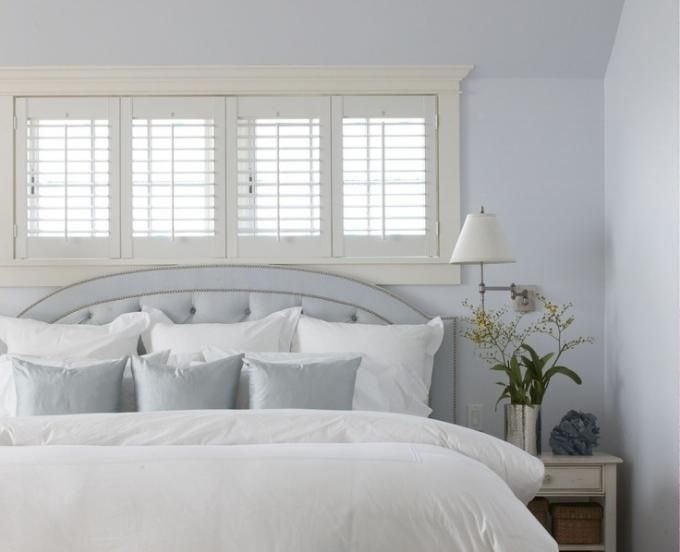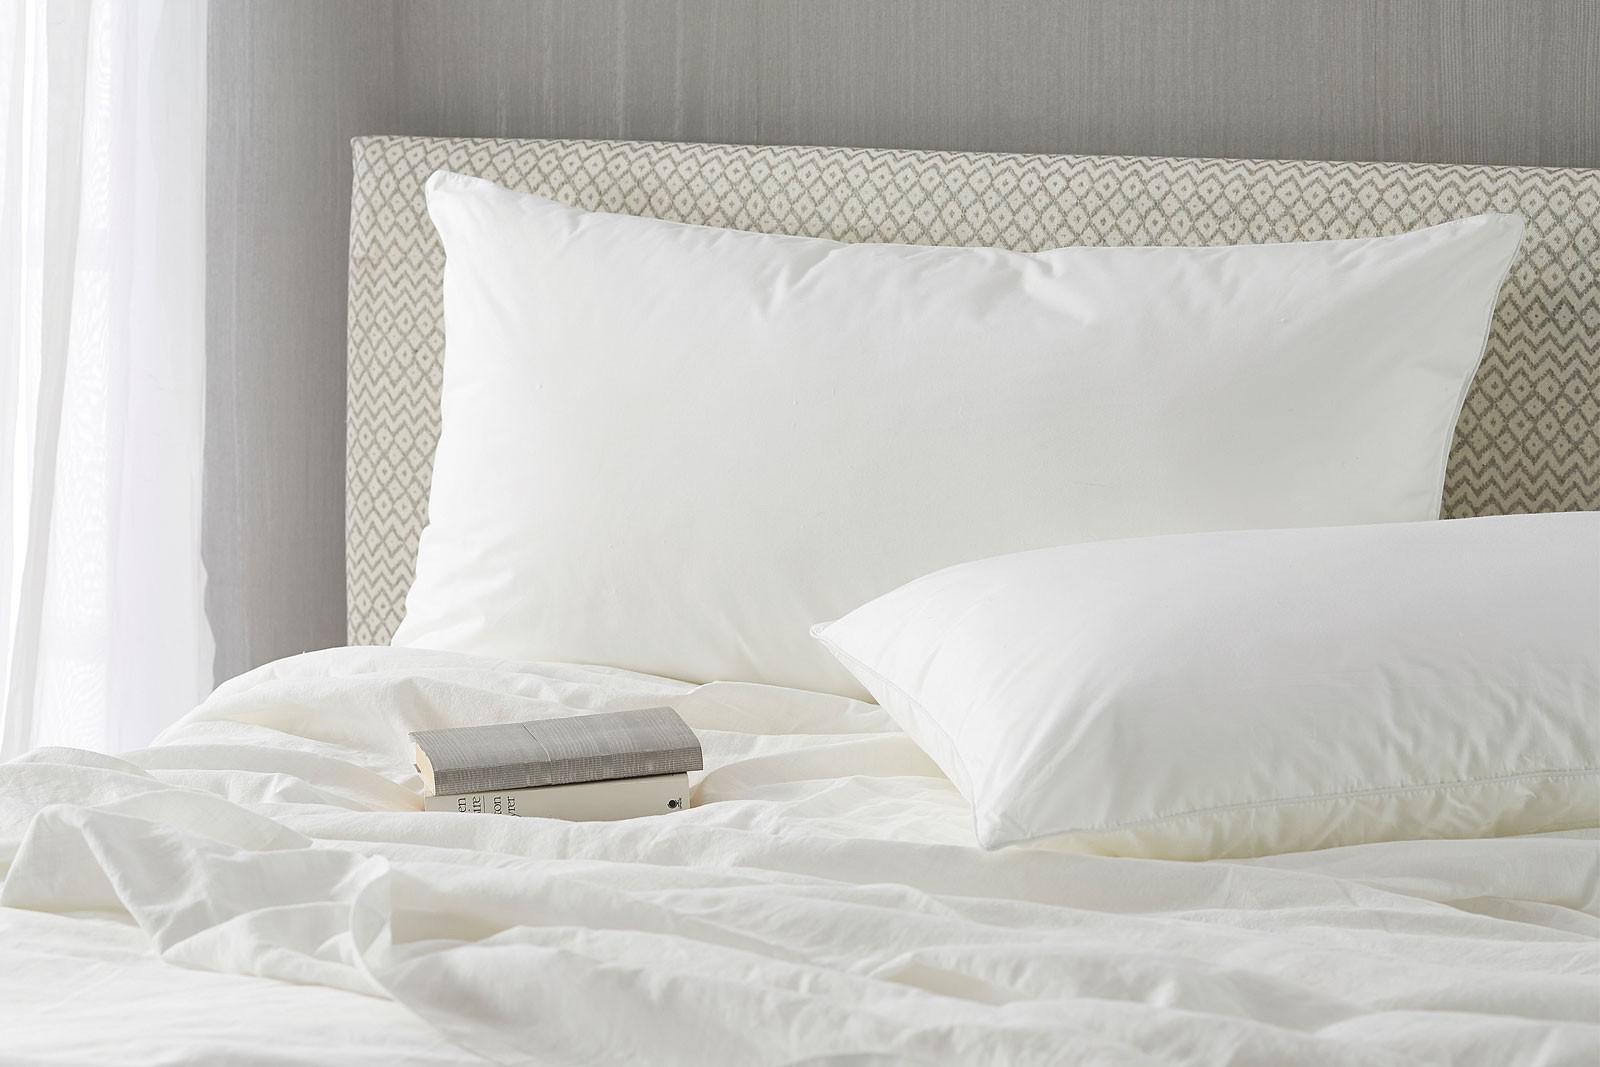The first image is the image on the left, the second image is the image on the right. For the images displayed, is the sentence "The pillows in the image on the left are propped against a padded headboard." factually correct? Answer yes or no. Yes. The first image is the image on the left, the second image is the image on the right. Assess this claim about the two images: "An image shows a bed with tufted headboard and at least six pillows.". Correct or not? Answer yes or no. Yes. 